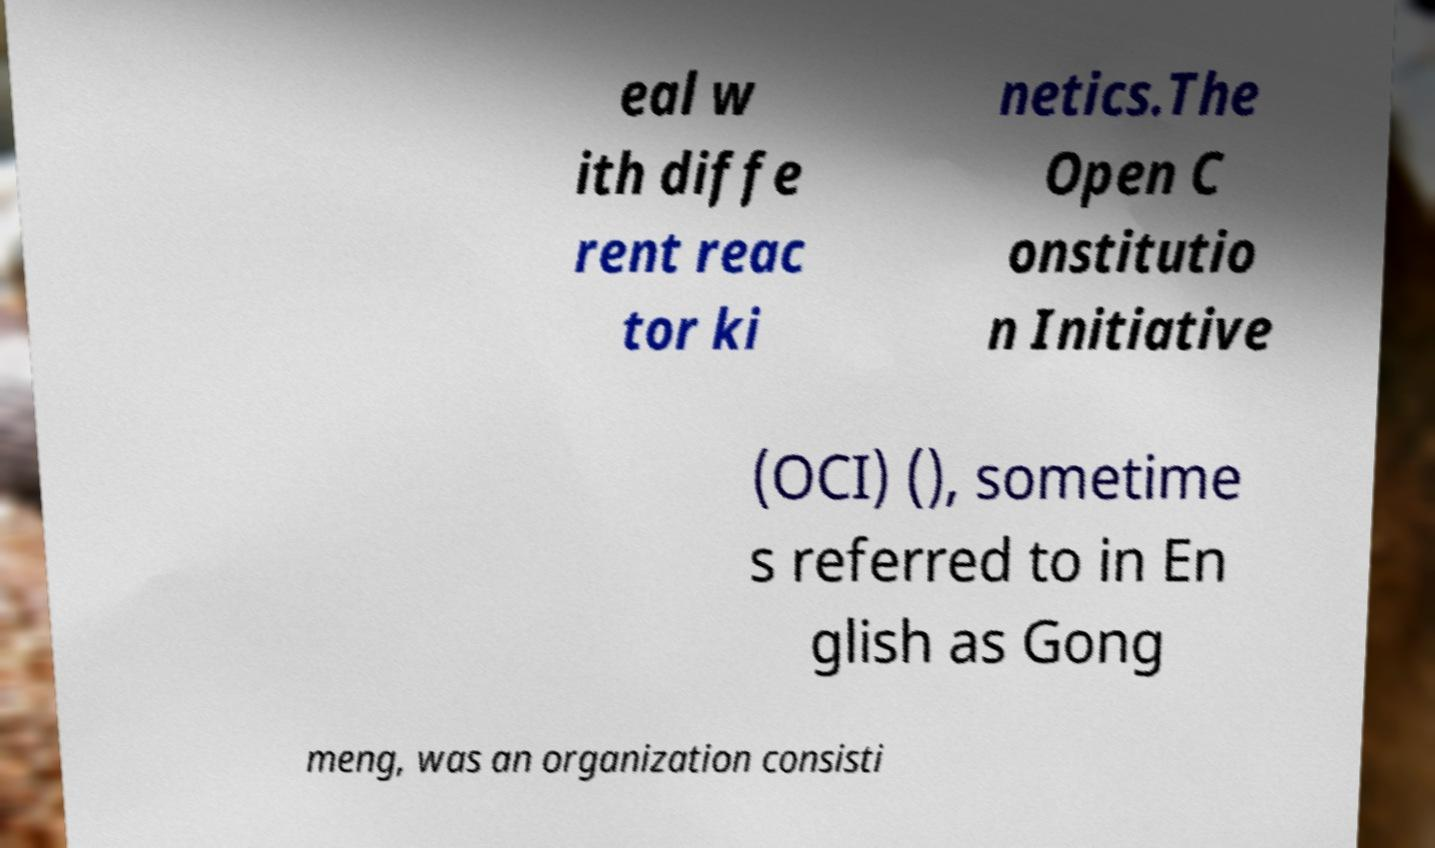For documentation purposes, I need the text within this image transcribed. Could you provide that? eal w ith diffe rent reac tor ki netics.The Open C onstitutio n Initiative (OCI) (), sometime s referred to in En glish as Gong meng, was an organization consisti 